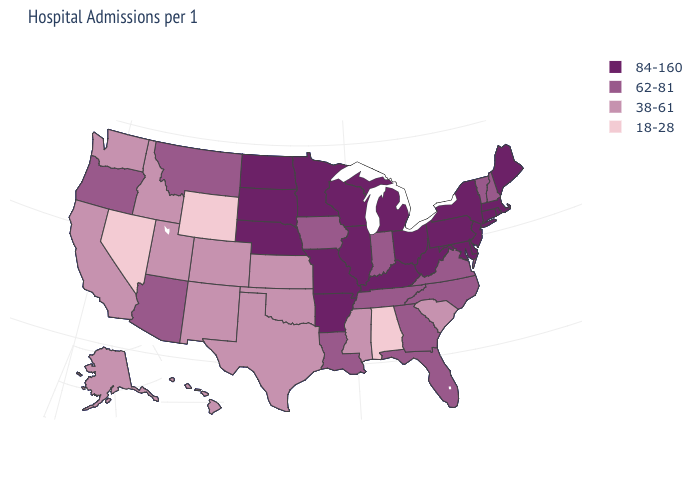Does California have the same value as Georgia?
Be succinct. No. Name the states that have a value in the range 38-61?
Give a very brief answer. Alaska, California, Colorado, Hawaii, Idaho, Kansas, Mississippi, New Mexico, Oklahoma, South Carolina, Texas, Utah, Washington. Name the states that have a value in the range 38-61?
Be succinct. Alaska, California, Colorado, Hawaii, Idaho, Kansas, Mississippi, New Mexico, Oklahoma, South Carolina, Texas, Utah, Washington. Name the states that have a value in the range 38-61?
Answer briefly. Alaska, California, Colorado, Hawaii, Idaho, Kansas, Mississippi, New Mexico, Oklahoma, South Carolina, Texas, Utah, Washington. Name the states that have a value in the range 18-28?
Short answer required. Alabama, Nevada, Wyoming. Does West Virginia have the highest value in the USA?
Be succinct. Yes. Does Arkansas have the lowest value in the USA?
Quick response, please. No. What is the value of Indiana?
Quick response, please. 62-81. What is the lowest value in states that border Kansas?
Write a very short answer. 38-61. What is the lowest value in the West?
Be succinct. 18-28. Among the states that border Rhode Island , which have the lowest value?
Short answer required. Connecticut, Massachusetts. Which states hav the highest value in the MidWest?
Short answer required. Illinois, Michigan, Minnesota, Missouri, Nebraska, North Dakota, Ohio, South Dakota, Wisconsin. Name the states that have a value in the range 38-61?
Write a very short answer. Alaska, California, Colorado, Hawaii, Idaho, Kansas, Mississippi, New Mexico, Oklahoma, South Carolina, Texas, Utah, Washington. Is the legend a continuous bar?
Write a very short answer. No. What is the lowest value in the USA?
Give a very brief answer. 18-28. 